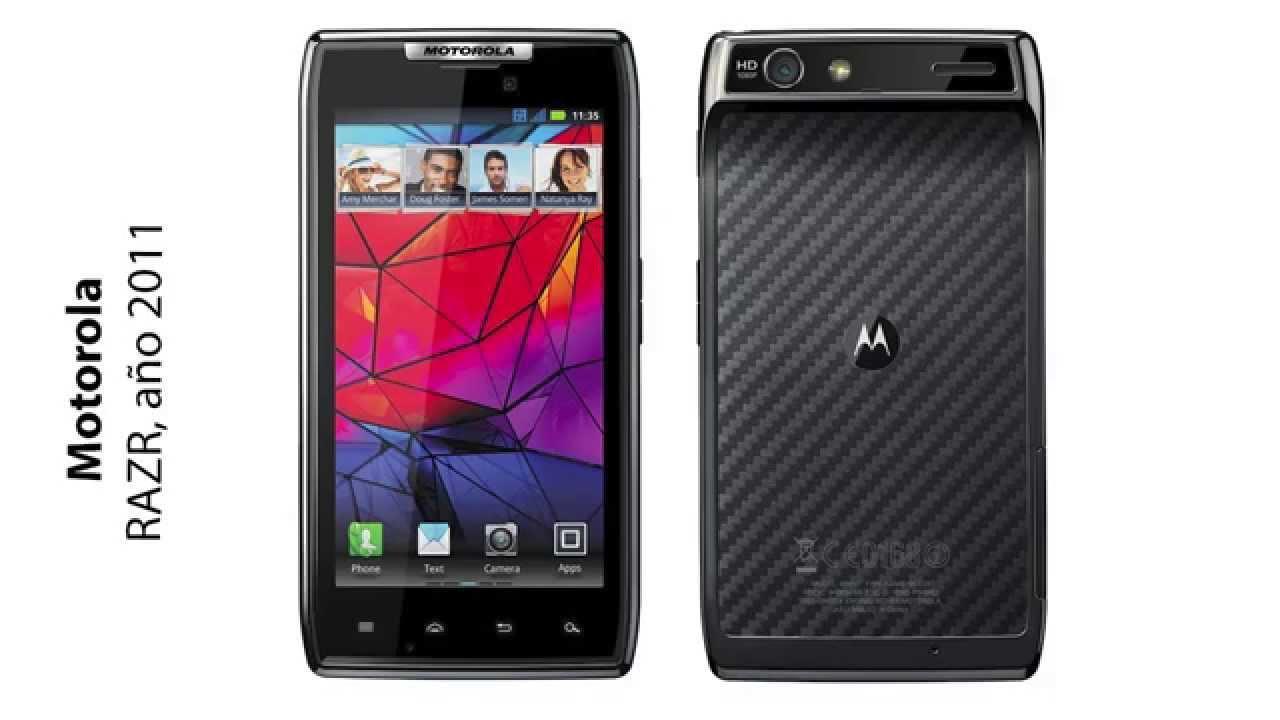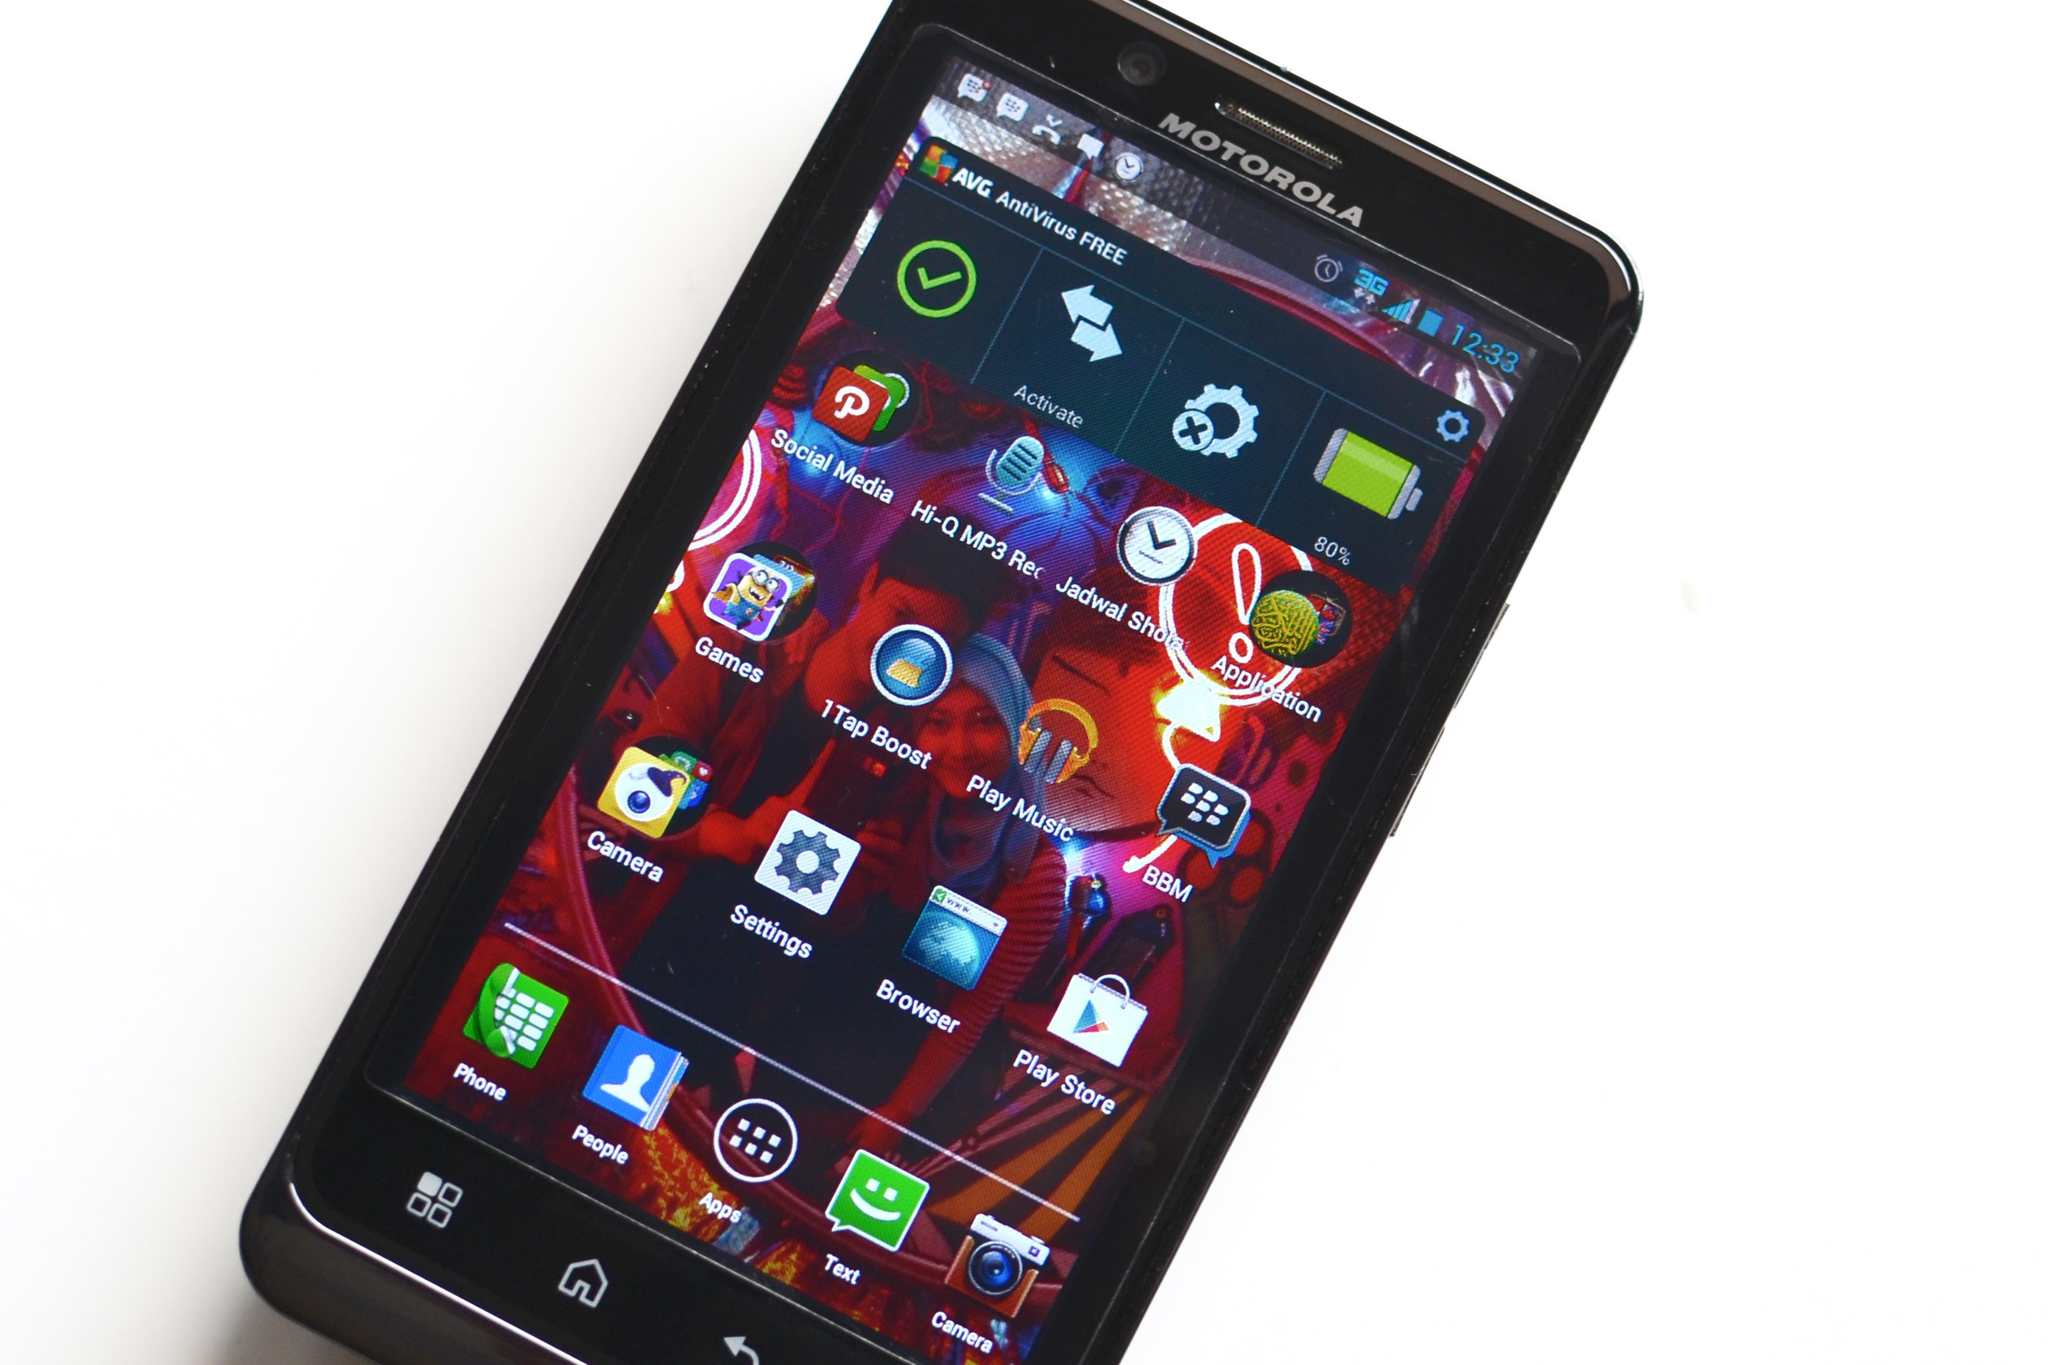The first image is the image on the left, the second image is the image on the right. Considering the images on both sides, is "A large assortment of cell phones are seen in both images." valid? Answer yes or no. No. The first image is the image on the left, the second image is the image on the right. For the images displayed, is the sentence "In both images there are many mobile phones from a variety of brands and models." factually correct? Answer yes or no. No. 